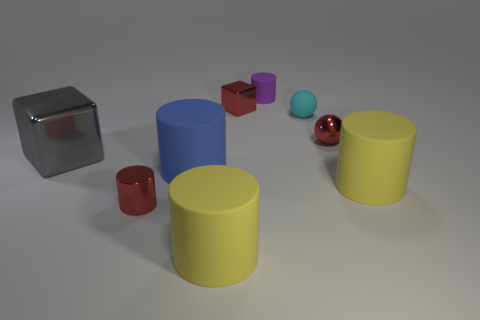Subtract all purple cylinders. How many cylinders are left? 4 Subtract all blue cylinders. How many cylinders are left? 4 Add 1 small red shiny things. How many objects exist? 10 Subtract all red cylinders. Subtract all blue cubes. How many cylinders are left? 4 Subtract all cubes. How many objects are left? 7 Add 5 big metallic objects. How many big metallic objects exist? 6 Subtract 1 red balls. How many objects are left? 8 Subtract all large shiny cubes. Subtract all matte balls. How many objects are left? 7 Add 9 gray blocks. How many gray blocks are left? 10 